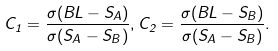Convert formula to latex. <formula><loc_0><loc_0><loc_500><loc_500>C _ { 1 } = \frac { \sigma ( B L - S _ { A } ) } { \sigma ( S _ { A } - S _ { B } ) } , C _ { 2 } = \frac { \sigma ( B L - S _ { B } ) } { \sigma ( S _ { A } - S _ { B } ) } .</formula> 